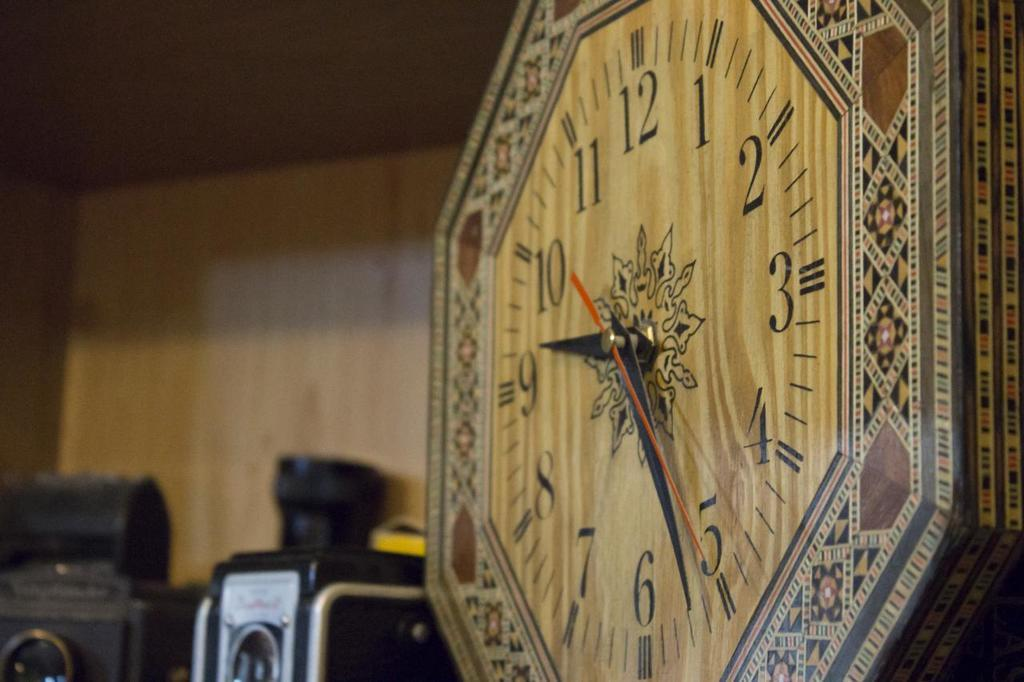<image>
Describe the image concisely. A wooden clock face shows the time at 9:26. 